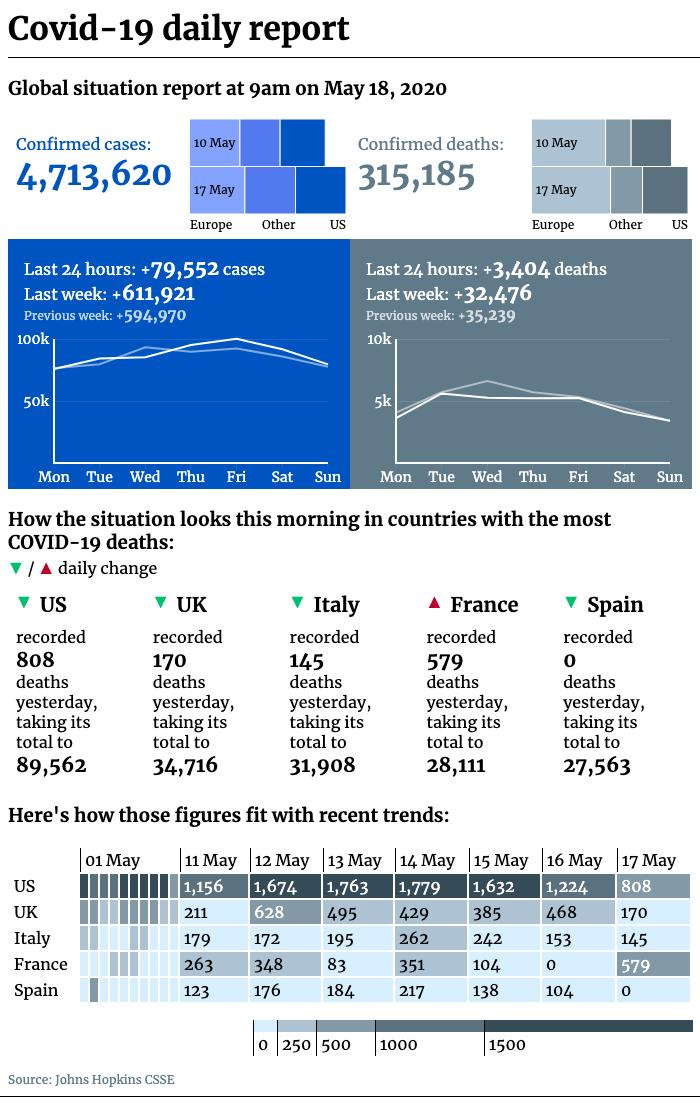Outline some significant characteristics in this image. As of May 18, 2020, a total of 315,185 confirmed COVID-19 deaths had been reported globally. As of May 18, 2020, the country with the highest number of COVID-19 deaths among the given countries is the United States. As of May 18, 2020, the number of confirmed cases of COVID-19 reported globally is 4,713,620. As of May 18, 2020, the total number of COVID-19 deaths reported in the UK was 34,716. As of May 18, 2020, the total number of COVID-19 deaths reported in Italy was 31,908. 